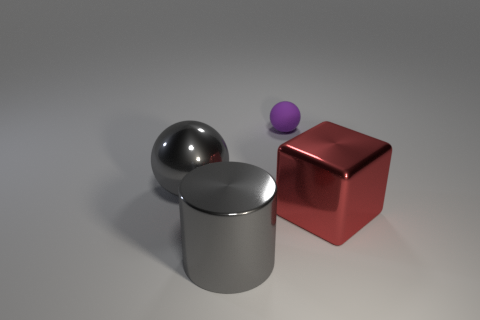Is there anything else that is the same material as the purple thing?
Your answer should be compact. No. How many other objects are the same shape as the small rubber thing?
Provide a succinct answer. 1. There is a metallic thing on the right side of the purple rubber ball; is it the same size as the thing behind the big gray ball?
Provide a short and direct response. No. What number of cubes are gray metal things or small purple rubber objects?
Your response must be concise. 0. What number of rubber objects are either tiny objects or large cubes?
Offer a very short reply. 1. What is the size of the metal thing that is the same shape as the tiny purple matte thing?
Provide a succinct answer. Large. Are there any other things that have the same size as the purple sphere?
Your answer should be compact. No. Is the size of the purple sphere the same as the red metal object that is right of the rubber sphere?
Your answer should be very brief. No. The gray thing in front of the large sphere has what shape?
Your response must be concise. Cylinder. There is a small rubber ball right of the gray sphere that is on the left side of the shiny cylinder; what color is it?
Make the answer very short. Purple. 